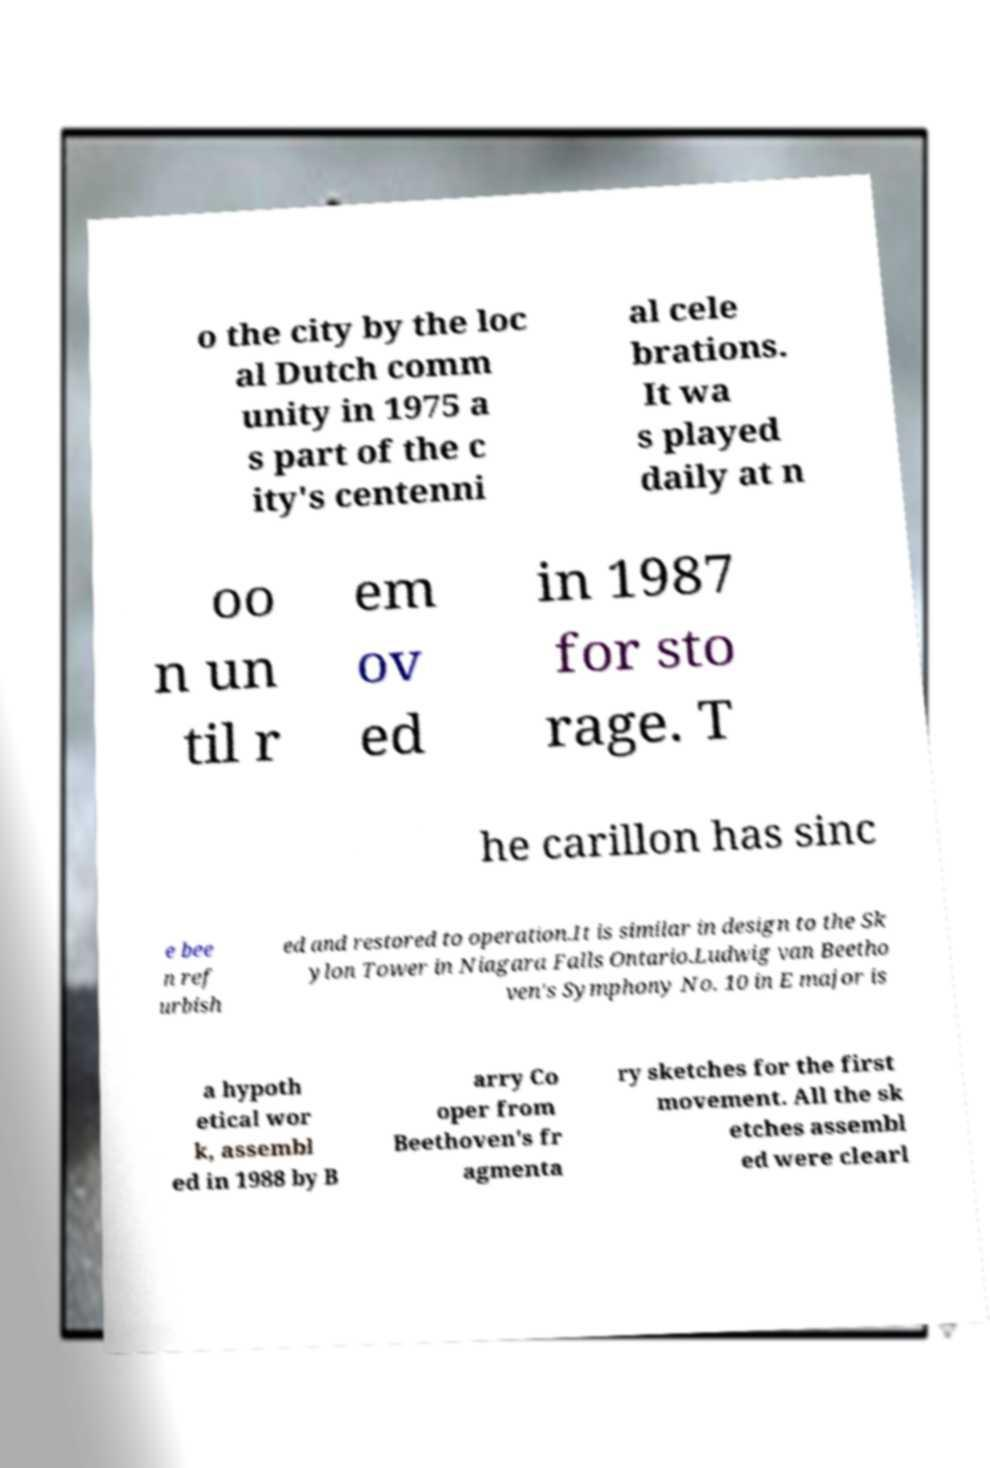Can you read and provide the text displayed in the image?This photo seems to have some interesting text. Can you extract and type it out for me? o the city by the loc al Dutch comm unity in 1975 a s part of the c ity's centenni al cele brations. It wa s played daily at n oo n un til r em ov ed in 1987 for sto rage. T he carillon has sinc e bee n ref urbish ed and restored to operation.It is similar in design to the Sk ylon Tower in Niagara Falls Ontario.Ludwig van Beetho ven's Symphony No. 10 in E major is a hypoth etical wor k, assembl ed in 1988 by B arry Co oper from Beethoven's fr agmenta ry sketches for the first movement. All the sk etches assembl ed were clearl 